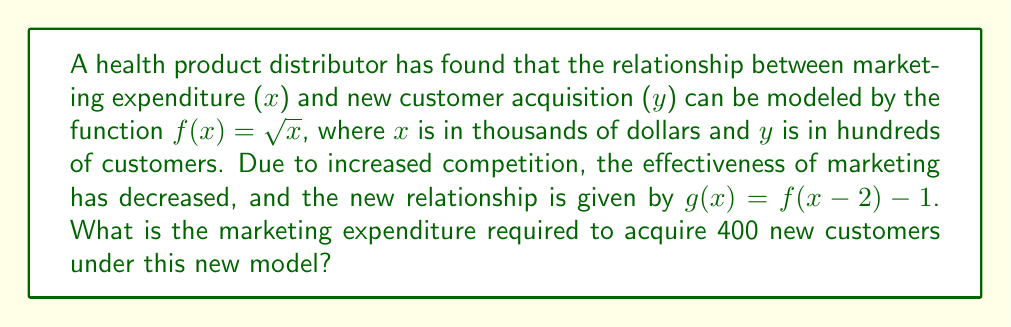Teach me how to tackle this problem. Let's approach this step-by-step:

1) We start with the original function $f(x) = \sqrt{x}$.

2) The new function $g(x)$ is a composition of two transformations on $f(x)$:
   - A horizontal shift of 2 units right: $f(x-2)$
   - A vertical shift of 1 unit down: $f(x-2) - 1$

3) So, $g(x) = \sqrt{x-2} - 1$

4) We want to find $x$ when $y = 400$ customers (which is 4 in our hundreds scale).

5) Let's set up the equation:
   $4 = \sqrt{x-2} - 1$

6) Solve for $x$:
   $5 = \sqrt{x-2}$
   $25 = x-2$
   $x = 27$

7) Remember, $x$ is in thousands of dollars. So the required marketing expenditure is $27,000.
Answer: $27,000 